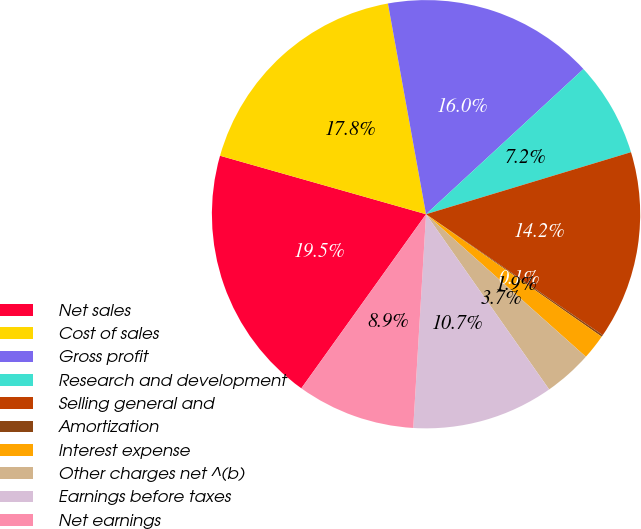<chart> <loc_0><loc_0><loc_500><loc_500><pie_chart><fcel>Net sales<fcel>Cost of sales<fcel>Gross profit<fcel>Research and development<fcel>Selling general and<fcel>Amortization<fcel>Interest expense<fcel>Other charges net ^(b)<fcel>Earnings before taxes<fcel>Net earnings<nl><fcel>19.51%<fcel>17.75%<fcel>15.99%<fcel>7.18%<fcel>14.23%<fcel>0.14%<fcel>1.9%<fcel>3.66%<fcel>10.7%<fcel>8.94%<nl></chart> 